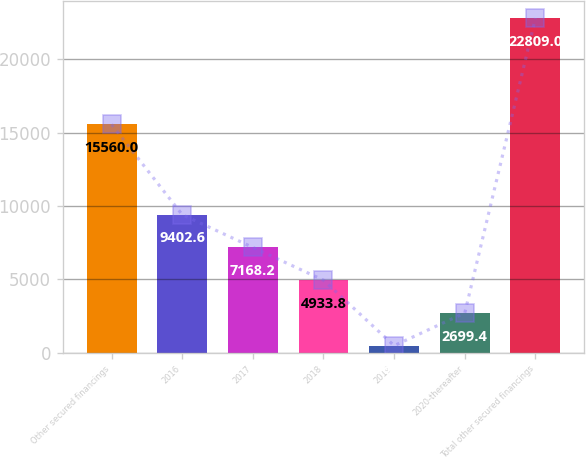Convert chart to OTSL. <chart><loc_0><loc_0><loc_500><loc_500><bar_chart><fcel>Other secured financings<fcel>2016<fcel>2017<fcel>2018<fcel>2019<fcel>2020-thereafter<fcel>Total other secured financings<nl><fcel>15560<fcel>9402.6<fcel>7168.2<fcel>4933.8<fcel>465<fcel>2699.4<fcel>22809<nl></chart> 